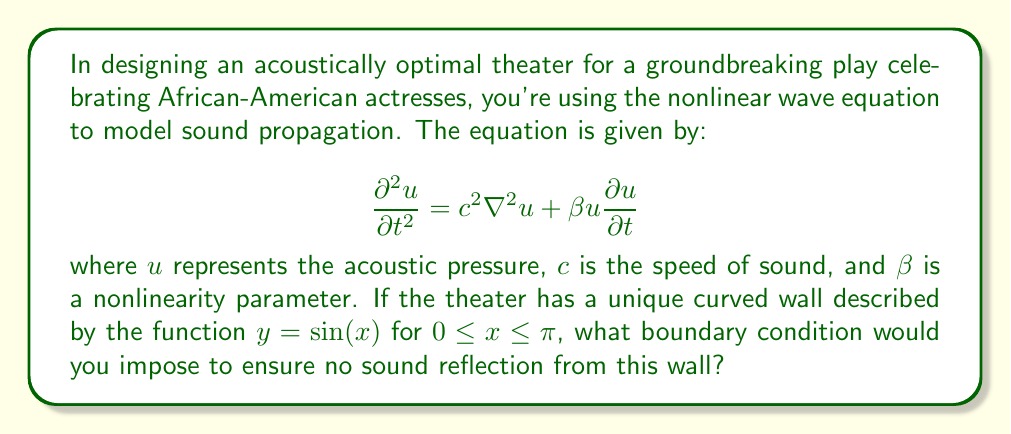Solve this math problem. To solve this problem, we need to follow these steps:

1) In acoustics, a non-reflecting boundary condition is known as an absorbing boundary condition. The most common type is the Sommerfeld radiation condition.

2) However, for a curved boundary, we need to modify this condition. We use the normal derivative to the boundary.

3) The general form of the absorbing boundary condition is:

   $$\frac{\partial u}{\partial n} + \frac{1}{c} \frac{\partial u}{\partial t} = 0$$

   where $n$ is the outward normal to the boundary.

4) For our curved wall $y = \sin(x)$, we need to find the normal vector. The tangent vector is:

   $$\vec{t} = (1, \cos(x))$$

5) The normal vector is perpendicular to the tangent vector:

   $$\vec{n} = (\cos(x), -1)$$

6) Normalizing this vector:

   $$\vec{n} = \frac{1}{\sqrt{1 + \cos^2(x)}}(\cos(x), -1)$$

7) Now, we can write our boundary condition:

   $$\frac{\cos(x)}{\sqrt{1 + \cos^2(x)}} \frac{\partial u}{\partial x} - \frac{1}{\sqrt{1 + \cos^2(x)}} \frac{\partial u}{\partial y} + \frac{1}{c} \frac{\partial u}{\partial t} = 0$$

This is the absorbing boundary condition for our curved wall.
Answer: $$\frac{\cos(x)}{\sqrt{1 + \cos^2(x)}} \frac{\partial u}{\partial x} - \frac{1}{\sqrt{1 + \cos^2(x)}} \frac{\partial u}{\partial y} + \frac{1}{c} \frac{\partial u}{\partial t} = 0$$ 